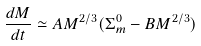Convert formula to latex. <formula><loc_0><loc_0><loc_500><loc_500>\frac { d M } { d t } \simeq A M ^ { 2 / 3 } ( \Sigma _ { m } ^ { 0 } - B M ^ { 2 / 3 } )</formula> 